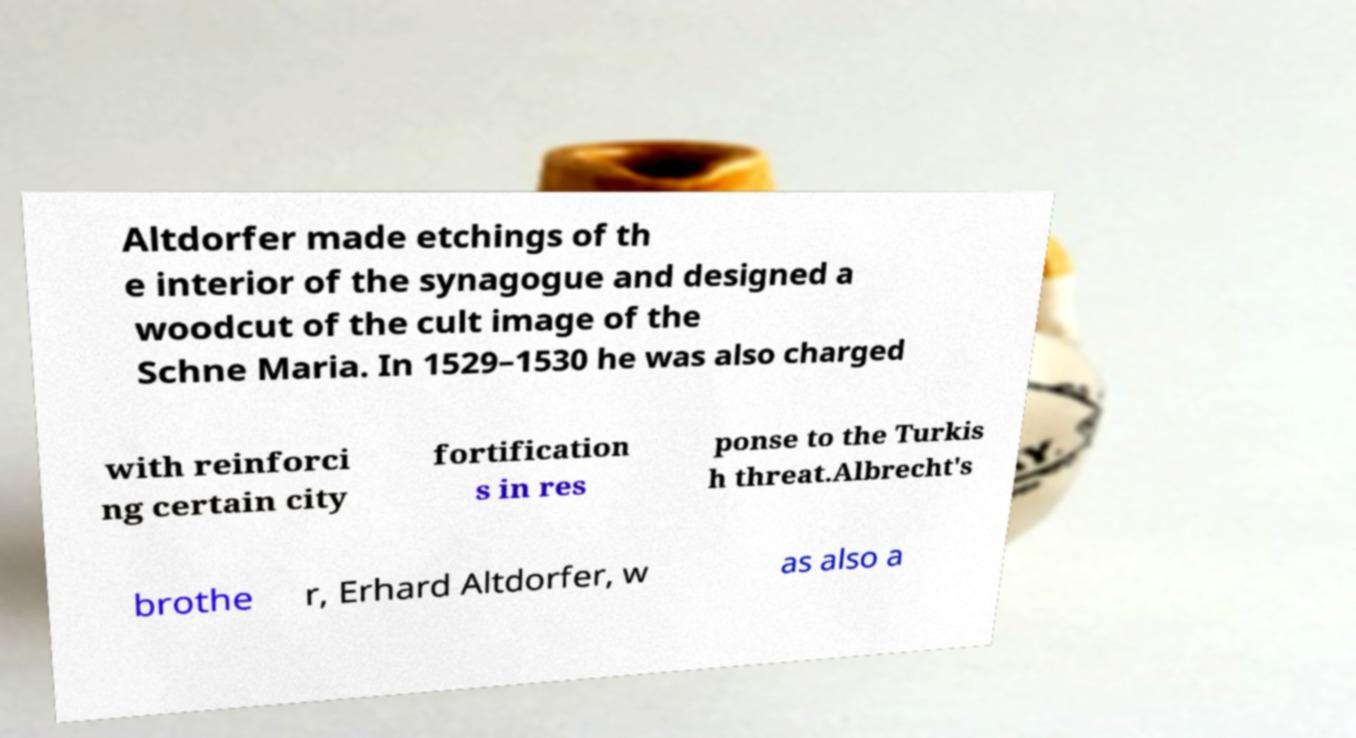Please read and relay the text visible in this image. What does it say? Altdorfer made etchings of th e interior of the synagogue and designed a woodcut of the cult image of the Schne Maria. In 1529–1530 he was also charged with reinforci ng certain city fortification s in res ponse to the Turkis h threat.Albrecht's brothe r, Erhard Altdorfer, w as also a 